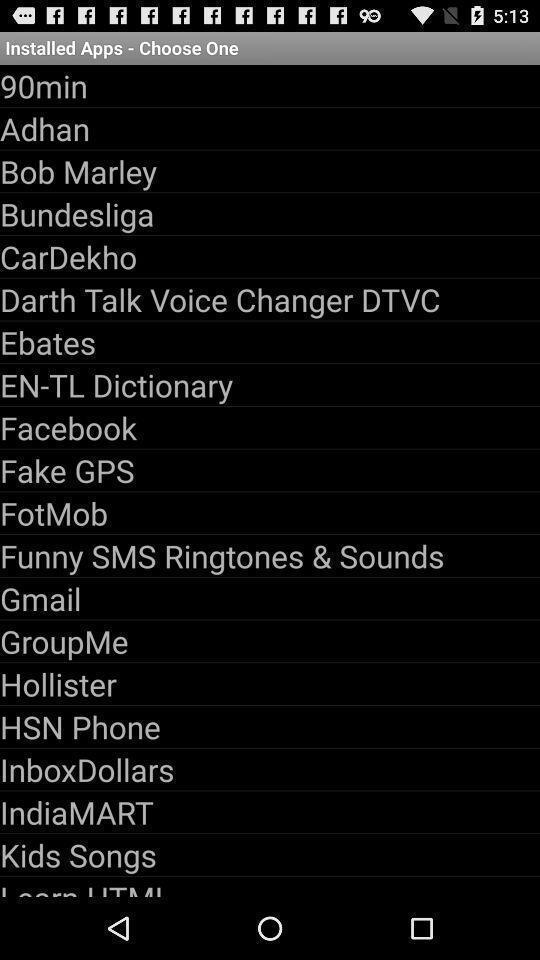Provide a detailed account of this screenshot. Page displaying with list of apps to install. 